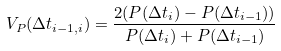Convert formula to latex. <formula><loc_0><loc_0><loc_500><loc_500>V _ { P } ( \Delta t _ { i - 1 , i } ) = \frac { 2 ( P ( \Delta t _ { i } ) - P ( \Delta t _ { i - 1 } ) ) } { P ( \Delta t _ { i } ) + P ( \Delta t _ { i - 1 } ) } \,</formula> 